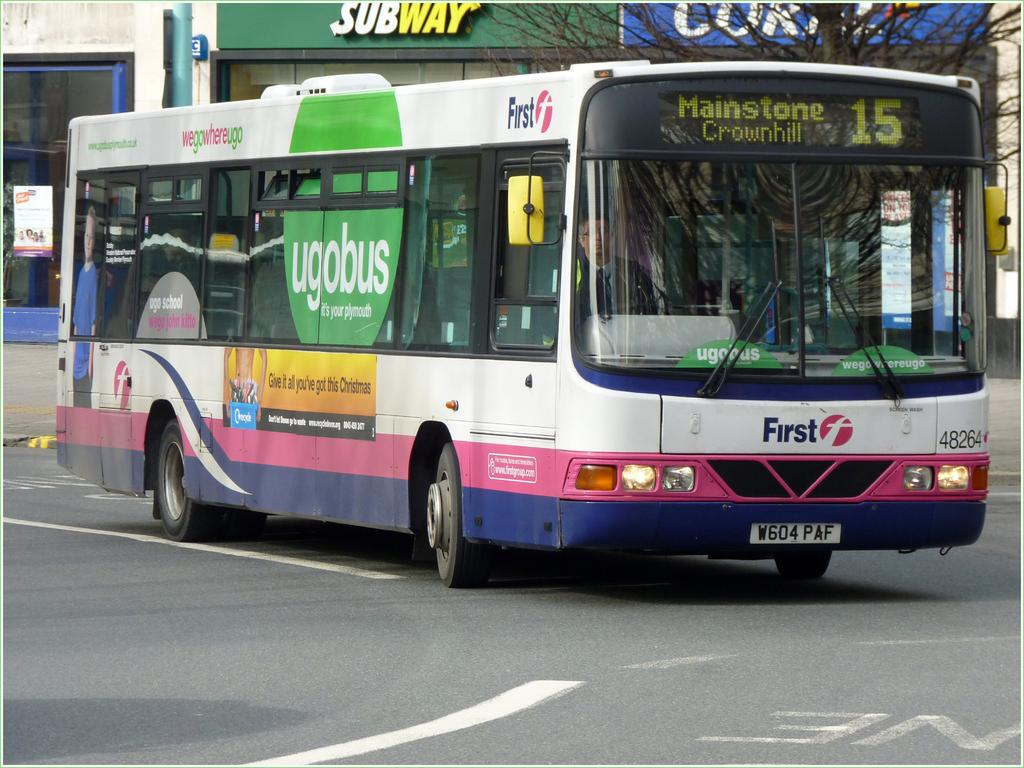<image>
Write a terse but informative summary of the picture. a colorful bus number 15 for Mainstone Crownhill 